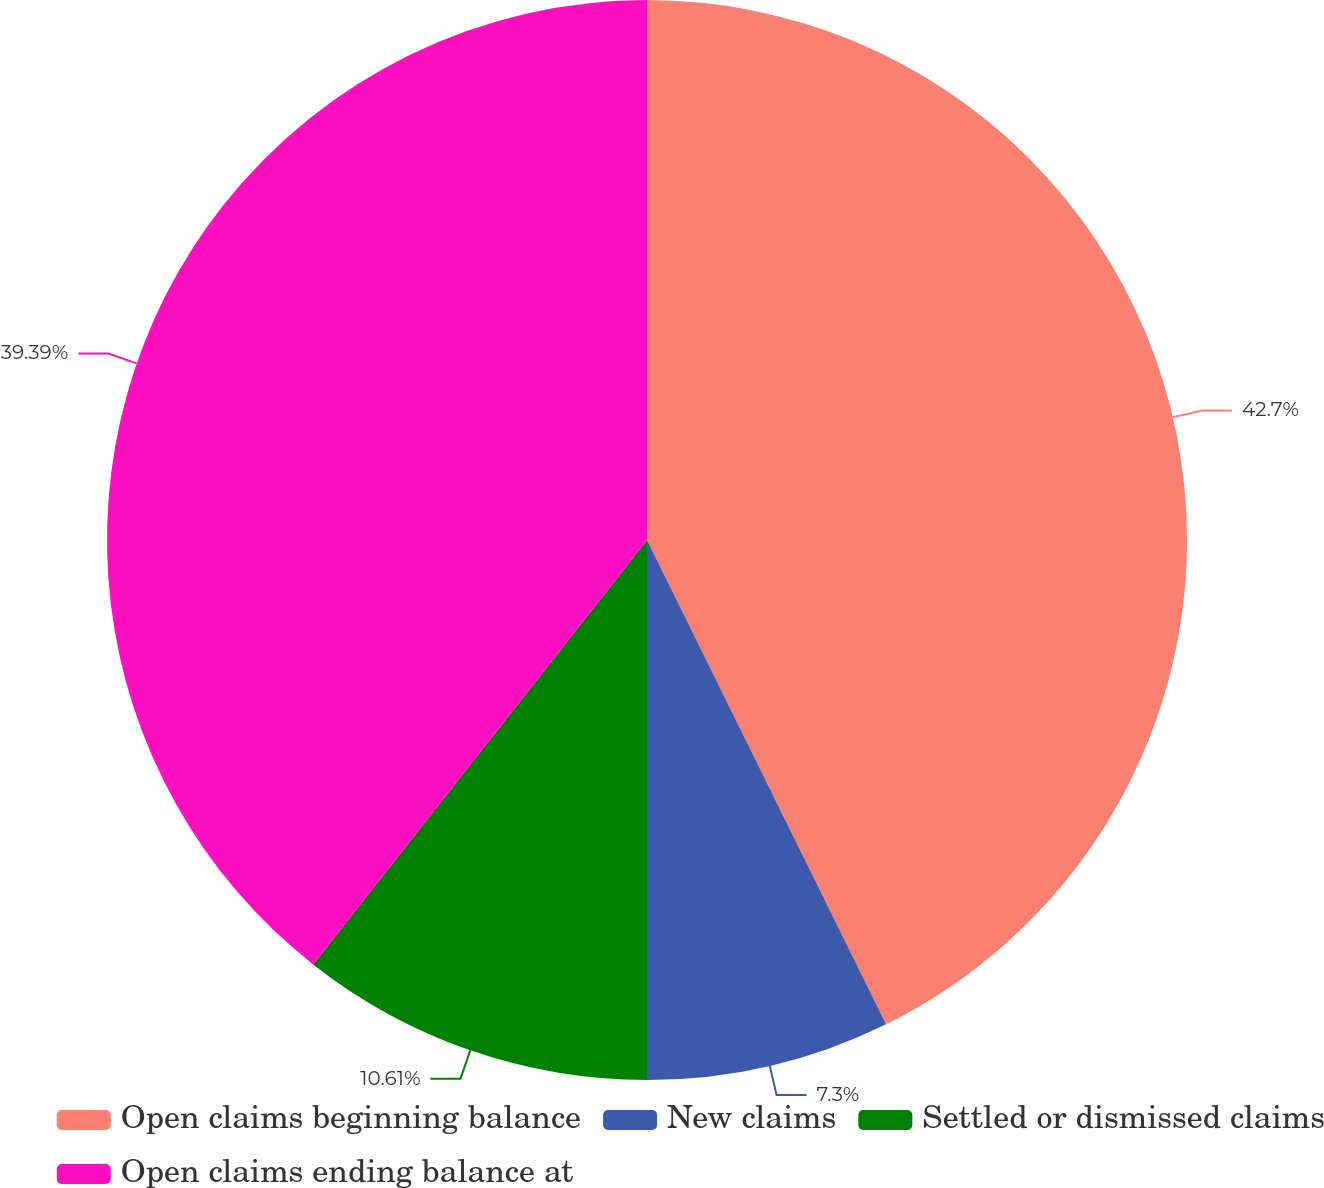Convert chart to OTSL. <chart><loc_0><loc_0><loc_500><loc_500><pie_chart><fcel>Open claims beginning balance<fcel>New claims<fcel>Settled or dismissed claims<fcel>Open claims ending balance at<nl><fcel>42.7%<fcel>7.3%<fcel>10.61%<fcel>39.39%<nl></chart> 